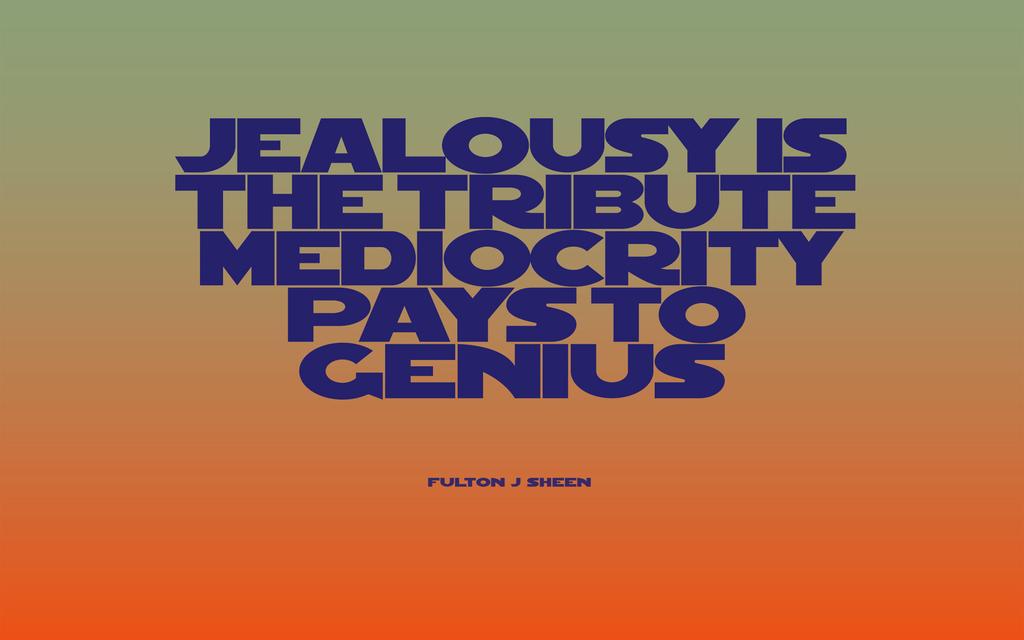Who wrote this quote?
Your response must be concise. Fulton j sheen. What is the first letter here?
Provide a succinct answer. J. 